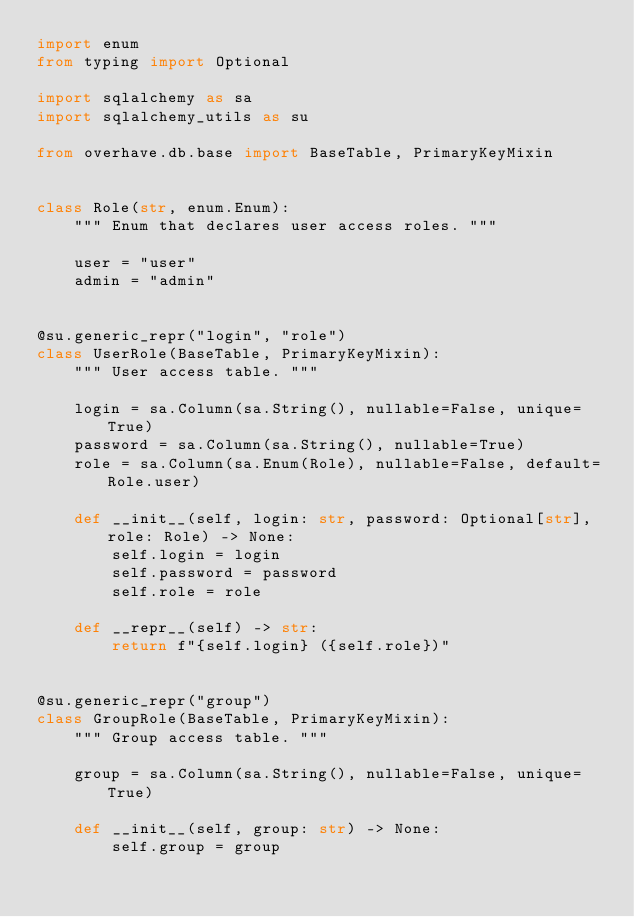<code> <loc_0><loc_0><loc_500><loc_500><_Python_>import enum
from typing import Optional

import sqlalchemy as sa
import sqlalchemy_utils as su

from overhave.db.base import BaseTable, PrimaryKeyMixin


class Role(str, enum.Enum):
    """ Enum that declares user access roles. """

    user = "user"
    admin = "admin"


@su.generic_repr("login", "role")
class UserRole(BaseTable, PrimaryKeyMixin):
    """ User access table. """

    login = sa.Column(sa.String(), nullable=False, unique=True)
    password = sa.Column(sa.String(), nullable=True)
    role = sa.Column(sa.Enum(Role), nullable=False, default=Role.user)

    def __init__(self, login: str, password: Optional[str], role: Role) -> None:
        self.login = login
        self.password = password
        self.role = role

    def __repr__(self) -> str:
        return f"{self.login} ({self.role})"


@su.generic_repr("group")
class GroupRole(BaseTable, PrimaryKeyMixin):
    """ Group access table. """

    group = sa.Column(sa.String(), nullable=False, unique=True)

    def __init__(self, group: str) -> None:
        self.group = group
</code> 